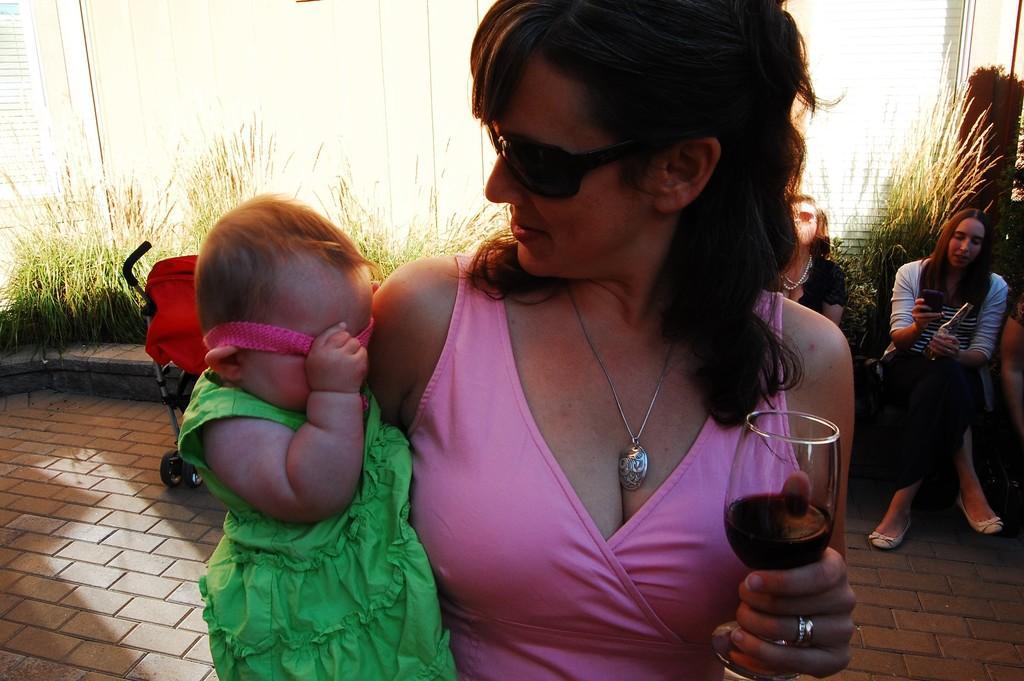Please provide a concise description of this image. In this image we can see a lady carrying a baby, she is holding a glass of drink, there are few other people sitting on the platform, there is a stroller, and the grass, also we can see the sky. 